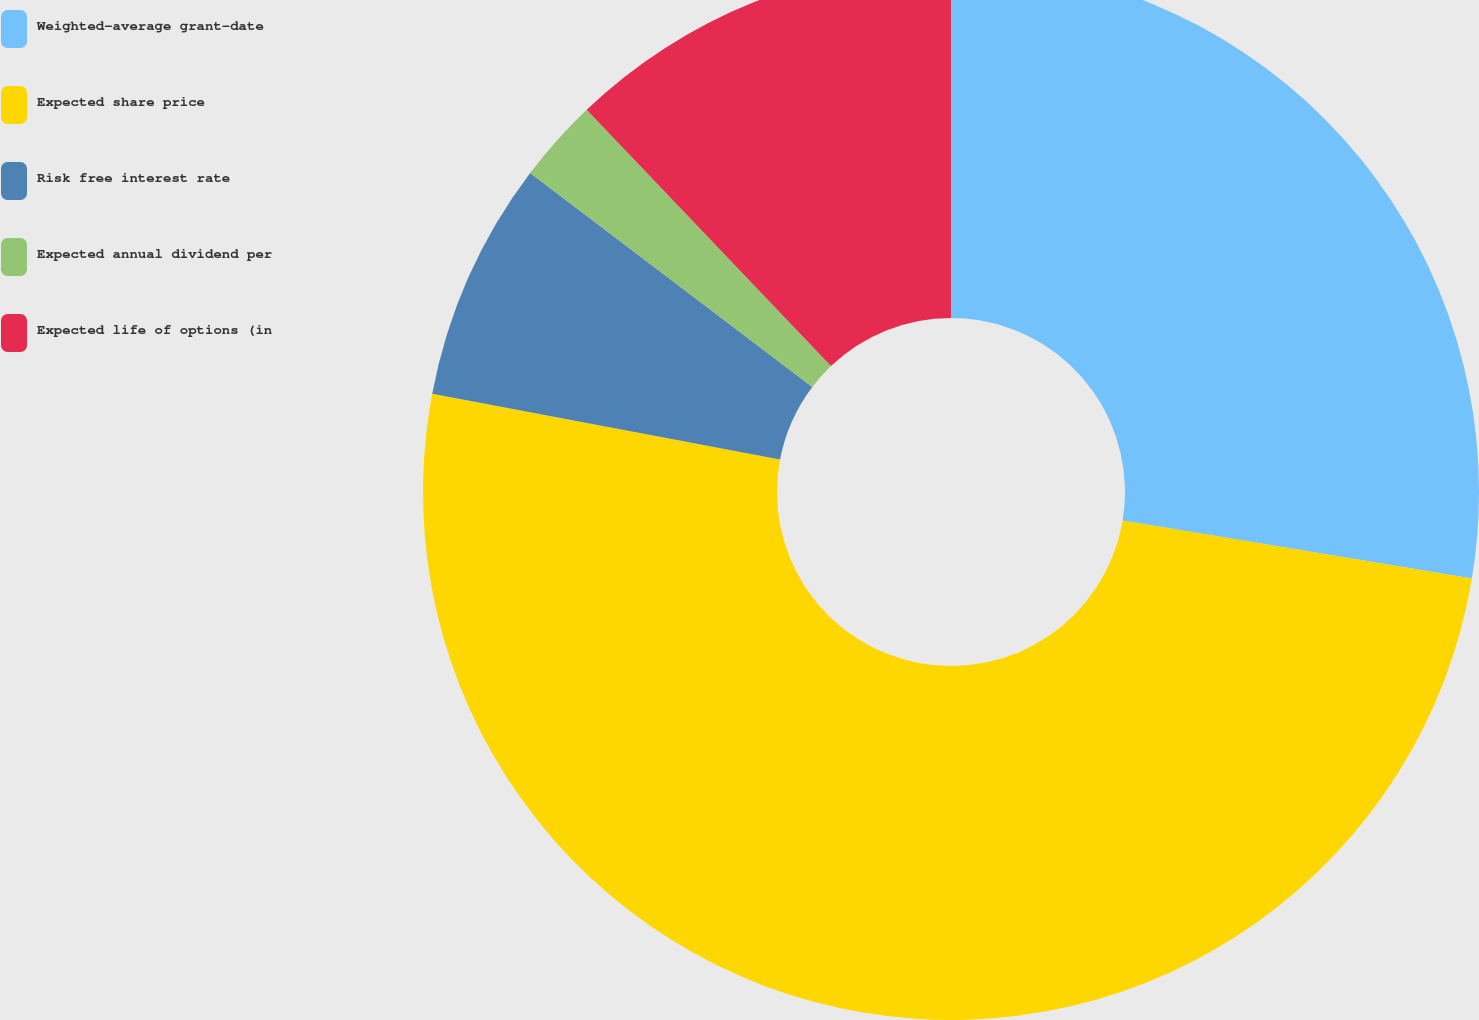<chart> <loc_0><loc_0><loc_500><loc_500><pie_chart><fcel>Weighted-average grant-date<fcel>Expected share price<fcel>Risk free interest rate<fcel>Expected annual dividend per<fcel>Expected life of options (in<nl><fcel>27.62%<fcel>50.36%<fcel>7.34%<fcel>2.56%<fcel>12.12%<nl></chart> 